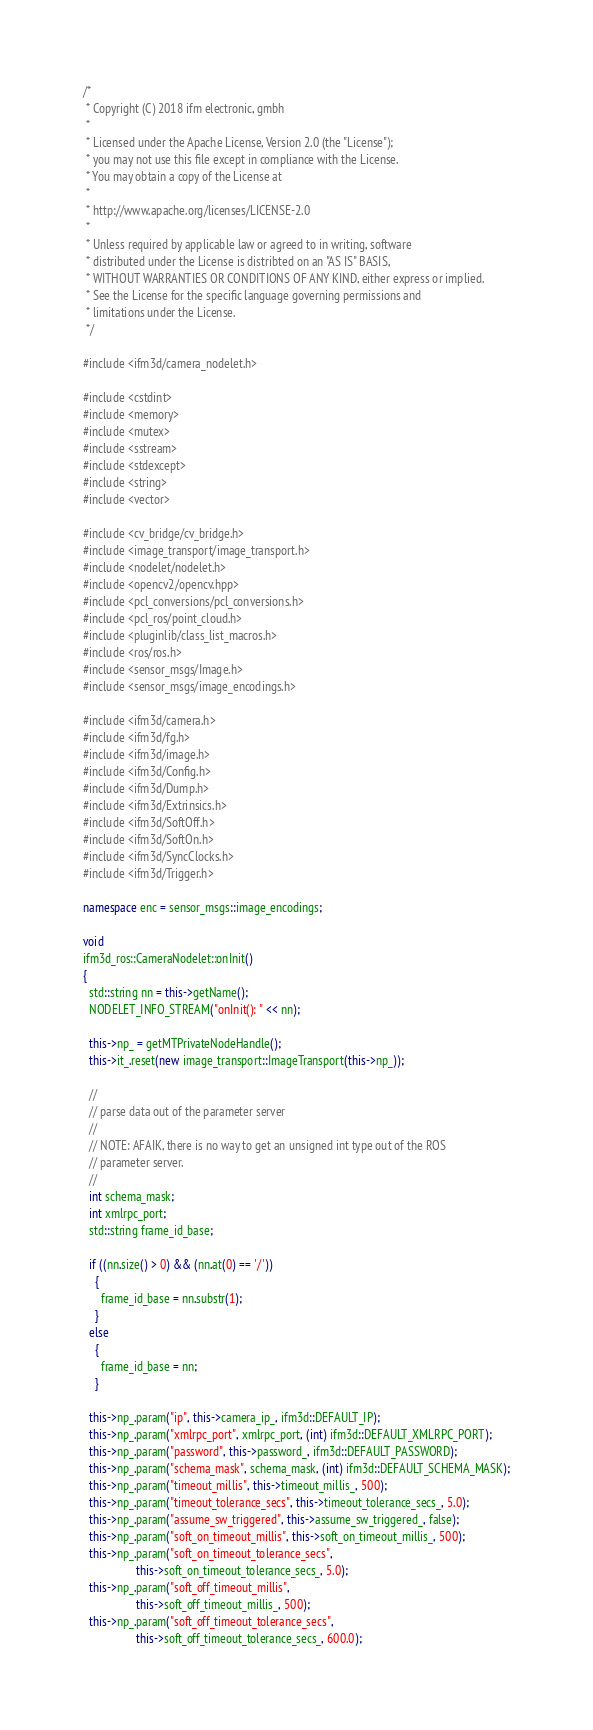<code> <loc_0><loc_0><loc_500><loc_500><_C++_>/*
 * Copyright (C) 2018 ifm electronic, gmbh
 *
 * Licensed under the Apache License, Version 2.0 (the "License");
 * you may not use this file except in compliance with the License.
 * You may obtain a copy of the License at
 *
 * http://www.apache.org/licenses/LICENSE-2.0
 *
 * Unless required by applicable law or agreed to in writing, software
 * distributed under the License is distribted on an "AS IS" BASIS,
 * WITHOUT WARRANTIES OR CONDITIONS OF ANY KIND, either express or implied.
 * See the License for the specific language governing permissions and
 * limitations under the License.
 */

#include <ifm3d/camera_nodelet.h>

#include <cstdint>
#include <memory>
#include <mutex>
#include <sstream>
#include <stdexcept>
#include <string>
#include <vector>

#include <cv_bridge/cv_bridge.h>
#include <image_transport/image_transport.h>
#include <nodelet/nodelet.h>
#include <opencv2/opencv.hpp>
#include <pcl_conversions/pcl_conversions.h>
#include <pcl_ros/point_cloud.h>
#include <pluginlib/class_list_macros.h>
#include <ros/ros.h>
#include <sensor_msgs/Image.h>
#include <sensor_msgs/image_encodings.h>

#include <ifm3d/camera.h>
#include <ifm3d/fg.h>
#include <ifm3d/image.h>
#include <ifm3d/Config.h>
#include <ifm3d/Dump.h>
#include <ifm3d/Extrinsics.h>
#include <ifm3d/SoftOff.h>
#include <ifm3d/SoftOn.h>
#include <ifm3d/SyncClocks.h>
#include <ifm3d/Trigger.h>

namespace enc = sensor_msgs::image_encodings;

void
ifm3d_ros::CameraNodelet::onInit()
{
  std::string nn = this->getName();
  NODELET_INFO_STREAM("onInit(): " << nn);

  this->np_ = getMTPrivateNodeHandle();
  this->it_.reset(new image_transport::ImageTransport(this->np_));

  //
  // parse data out of the parameter server
  //
  // NOTE: AFAIK, there is no way to get an unsigned int type out of the ROS
  // parameter server.
  //
  int schema_mask;
  int xmlrpc_port;
  std::string frame_id_base;

  if ((nn.size() > 0) && (nn.at(0) == '/'))
    {
      frame_id_base = nn.substr(1);
    }
  else
    {
      frame_id_base = nn;
    }

  this->np_.param("ip", this->camera_ip_, ifm3d::DEFAULT_IP);
  this->np_.param("xmlrpc_port", xmlrpc_port, (int) ifm3d::DEFAULT_XMLRPC_PORT);
  this->np_.param("password", this->password_, ifm3d::DEFAULT_PASSWORD);
  this->np_.param("schema_mask", schema_mask, (int) ifm3d::DEFAULT_SCHEMA_MASK);
  this->np_.param("timeout_millis", this->timeout_millis_, 500);
  this->np_.param("timeout_tolerance_secs", this->timeout_tolerance_secs_, 5.0);
  this->np_.param("assume_sw_triggered", this->assume_sw_triggered_, false);
  this->np_.param("soft_on_timeout_millis", this->soft_on_timeout_millis_, 500);
  this->np_.param("soft_on_timeout_tolerance_secs",
                  this->soft_on_timeout_tolerance_secs_, 5.0);
  this->np_.param("soft_off_timeout_millis",
                  this->soft_off_timeout_millis_, 500);
  this->np_.param("soft_off_timeout_tolerance_secs",
                  this->soft_off_timeout_tolerance_secs_, 600.0);</code> 